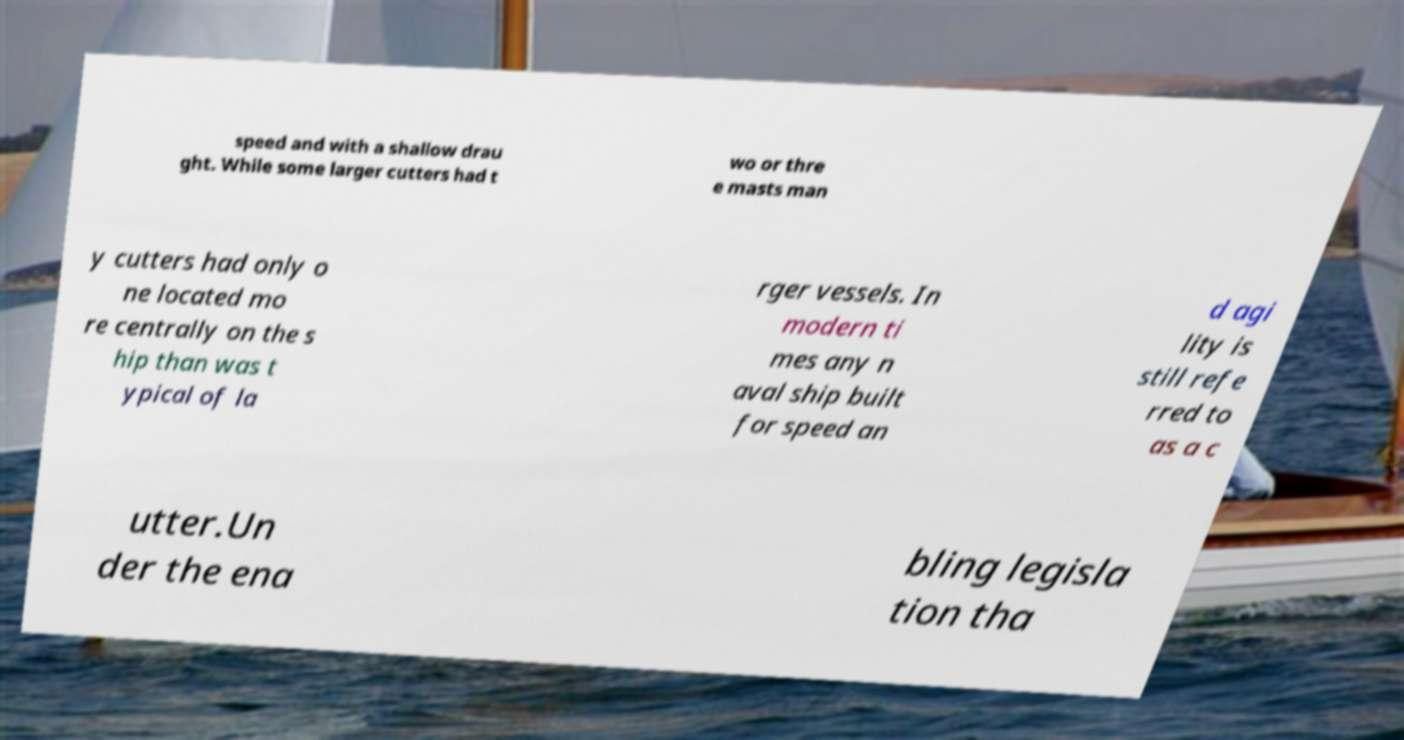Can you read and provide the text displayed in the image?This photo seems to have some interesting text. Can you extract and type it out for me? speed and with a shallow drau ght. While some larger cutters had t wo or thre e masts man y cutters had only o ne located mo re centrally on the s hip than was t ypical of la rger vessels. In modern ti mes any n aval ship built for speed an d agi lity is still refe rred to as a c utter.Un der the ena bling legisla tion tha 